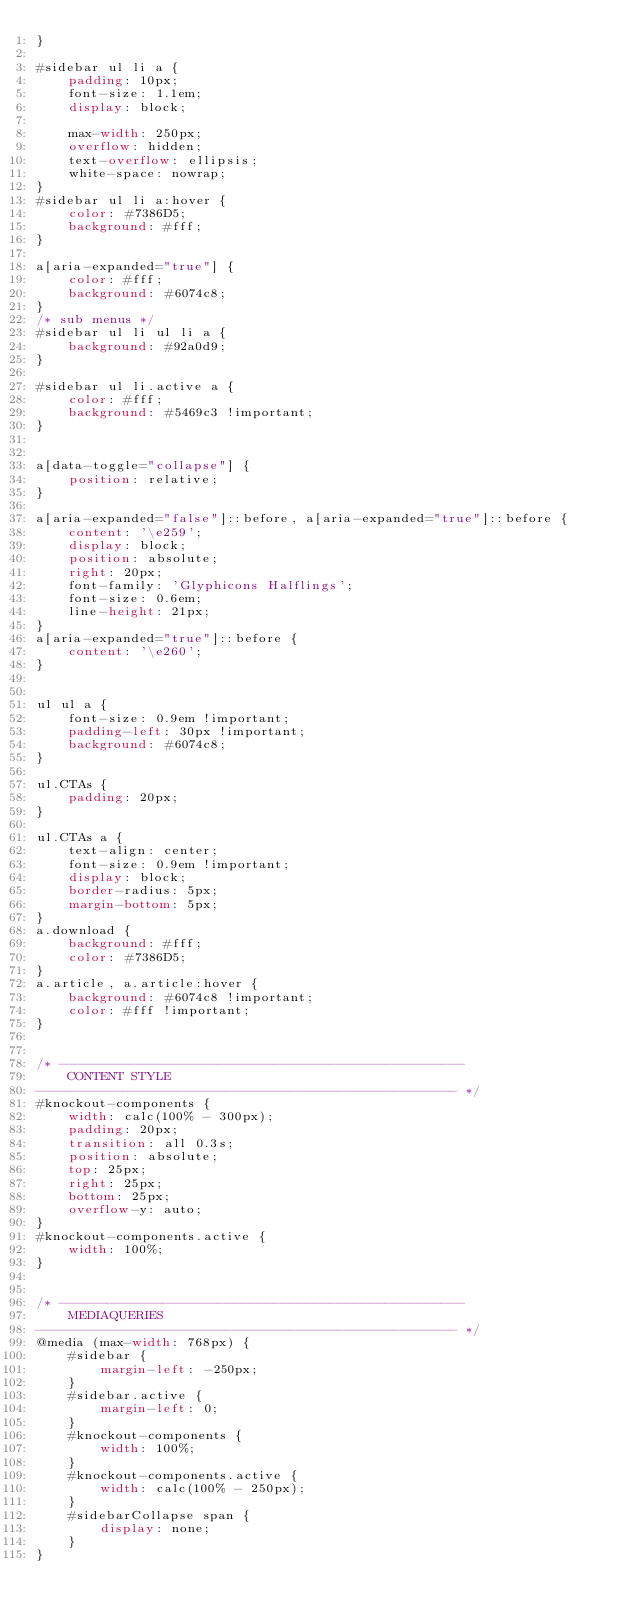<code> <loc_0><loc_0><loc_500><loc_500><_CSS_>}

#sidebar ul li a {
    padding: 10px;
    font-size: 1.1em;
    display: block;

    max-width: 250px;
    overflow: hidden;
    text-overflow: ellipsis;
    white-space: nowrap;
}
#sidebar ul li a:hover {
    color: #7386D5;
    background: #fff;
}

a[aria-expanded="true"] {
    color: #fff;
    background: #6074c8;
}
/* sub menus */
#sidebar ul li ul li a {
    background: #92a0d9;
}

#sidebar ul li.active a {
    color: #fff;
    background: #5469c3 !important;
}


a[data-toggle="collapse"] {
    position: relative;
}

a[aria-expanded="false"]::before, a[aria-expanded="true"]::before {
    content: '\e259';
    display: block;
    position: absolute;
    right: 20px;
    font-family: 'Glyphicons Halflings';
    font-size: 0.6em;
    line-height: 21px;
}
a[aria-expanded="true"]::before {
    content: '\e260';
}


ul ul a {
    font-size: 0.9em !important;
    padding-left: 30px !important;
    background: #6074c8;
}

ul.CTAs {
    padding: 20px;
}

ul.CTAs a {
    text-align: center;
    font-size: 0.9em !important;
    display: block;
    border-radius: 5px;
    margin-bottom: 5px;
}
a.download {
    background: #fff;
    color: #7386D5;
}
a.article, a.article:hover {
    background: #6074c8 !important;
    color: #fff !important;
}


/* ---------------------------------------------------
    CONTENT STYLE
----------------------------------------------------- */
#knockout-components {
    width: calc(100% - 300px);
    padding: 20px;
    transition: all 0.3s;
    position: absolute;
    top: 25px;
    right: 25px;
    bottom: 25px;
    overflow-y: auto;
}
#knockout-components.active {
    width: 100%;
}


/* ---------------------------------------------------
    MEDIAQUERIES
----------------------------------------------------- */
@media (max-width: 768px) {
    #sidebar {
        margin-left: -250px;
    }
    #sidebar.active {
        margin-left: 0;
    }
    #knockout-components {
        width: 100%;
    }
    #knockout-components.active {
        width: calc(100% - 250px);
    }
    #sidebarCollapse span {
        display: none;
    }
}
</code> 